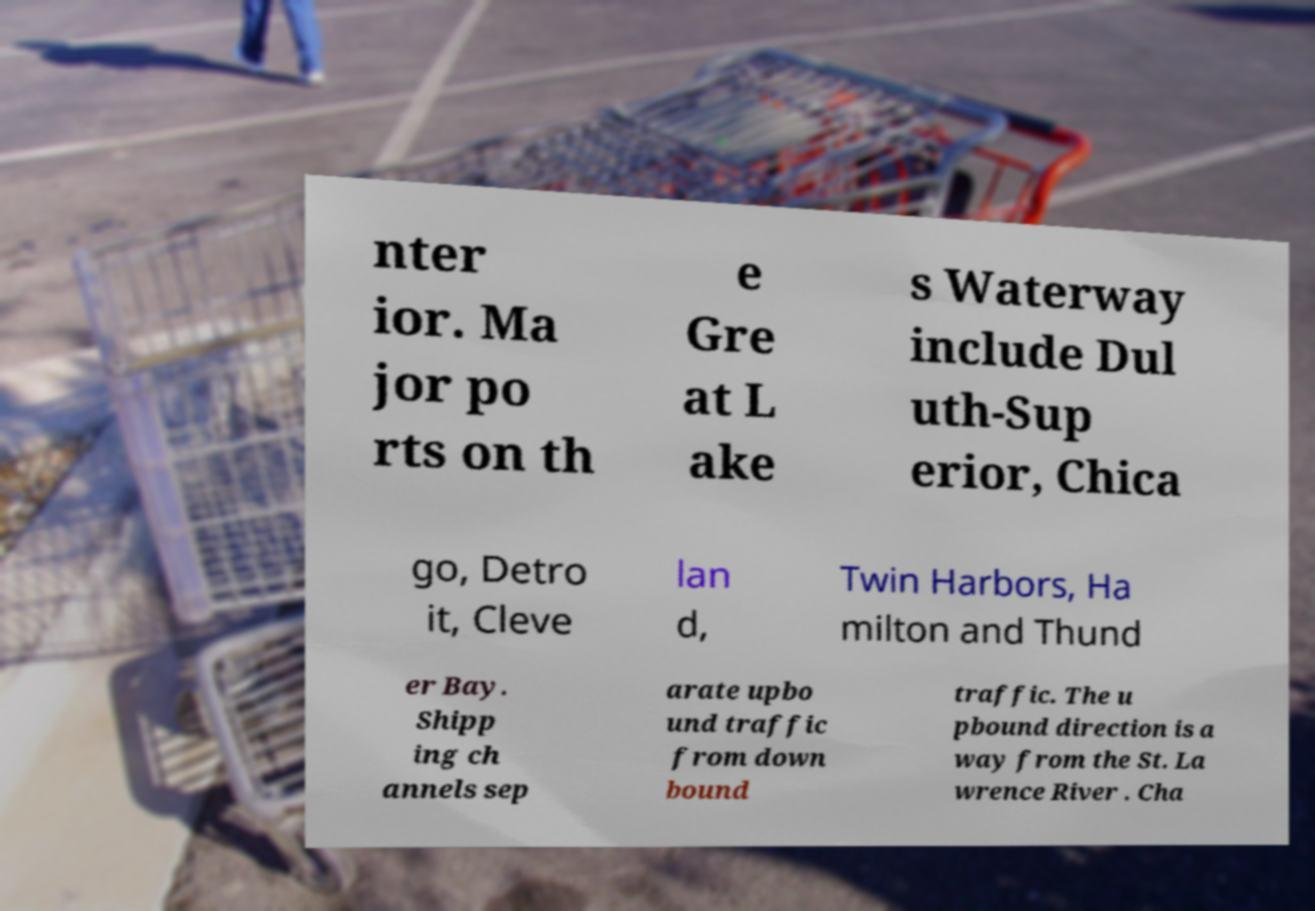For documentation purposes, I need the text within this image transcribed. Could you provide that? nter ior. Ma jor po rts on th e Gre at L ake s Waterway include Dul uth-Sup erior, Chica go, Detro it, Cleve lan d, Twin Harbors, Ha milton and Thund er Bay. Shipp ing ch annels sep arate upbo und traffic from down bound traffic. The u pbound direction is a way from the St. La wrence River . Cha 